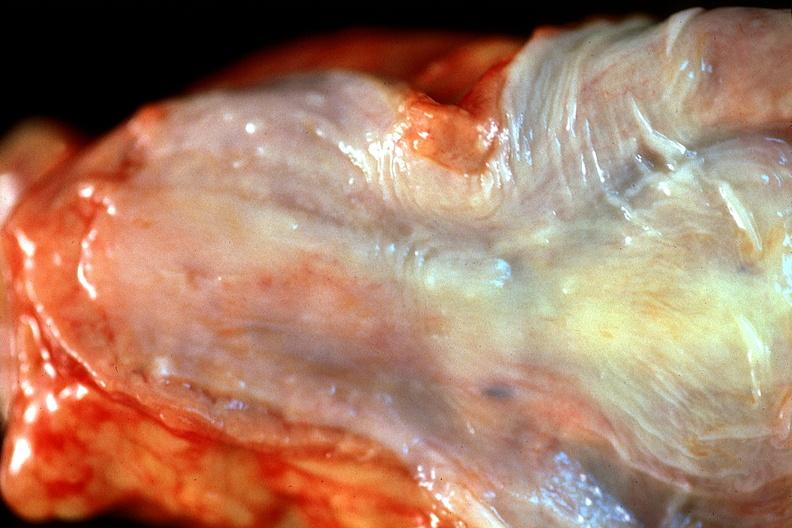s peritoneum present?
Answer the question using a single word or phrase. No 